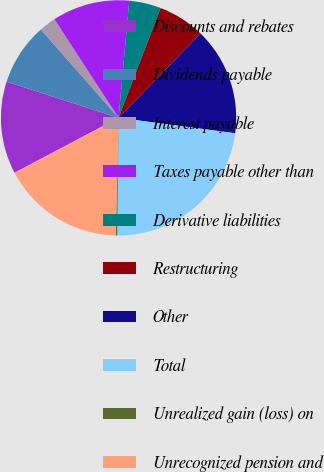<chart> <loc_0><loc_0><loc_500><loc_500><pie_chart><fcel>Discounts and rebates<fcel>Dividends payable<fcel>Interest payable<fcel>Taxes payable other than<fcel>Derivative liabilities<fcel>Restructuring<fcel>Other<fcel>Total<fcel>Unrealized gain (loss) on<fcel>Unrecognized pension and<nl><fcel>12.72%<fcel>8.55%<fcel>2.29%<fcel>10.63%<fcel>4.37%<fcel>6.46%<fcel>14.81%<fcel>23.09%<fcel>0.2%<fcel>16.89%<nl></chart> 